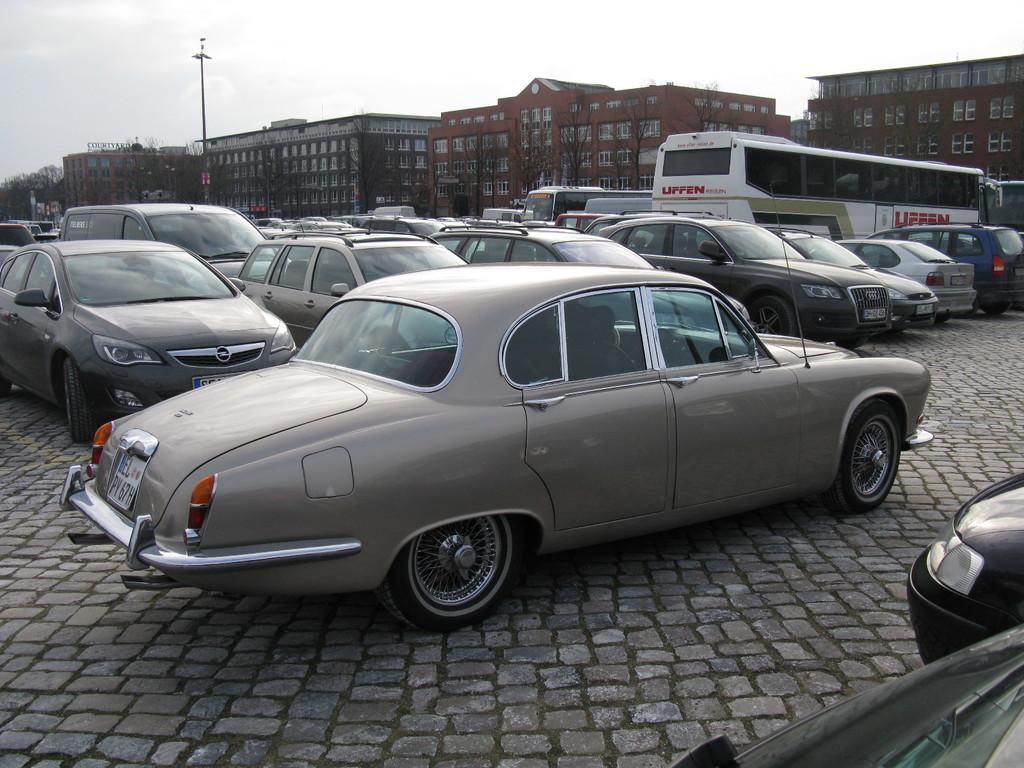What types of vehicles are parked in the image? There are cars and buses parked in the image. What can be seen in the background of the image? There are buildings visible in the background of the image. What object is present in the image that is not a vehicle or building? A pole is present in the image. What is the condition of the sky in the image? The sky is full of clouds in the image. What type of instrument is being played by the root in the image? There is no root or instrument present in the image. 